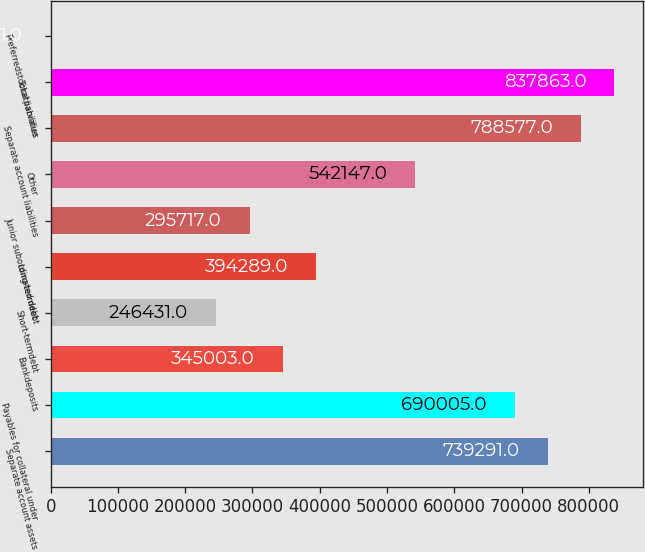Convert chart to OTSL. <chart><loc_0><loc_0><loc_500><loc_500><bar_chart><fcel>Separate account assets<fcel>Payables for collateral under<fcel>Bankdeposits<fcel>Short-termdebt<fcel>Long-termdebt<fcel>Junior subordinated debt<fcel>Other<fcel>Separate account liabilities<fcel>Total liabilities<fcel>Preferredstockatparvalue<nl><fcel>739291<fcel>690005<fcel>345003<fcel>246431<fcel>394289<fcel>295717<fcel>542147<fcel>788577<fcel>837863<fcel>1<nl></chart> 